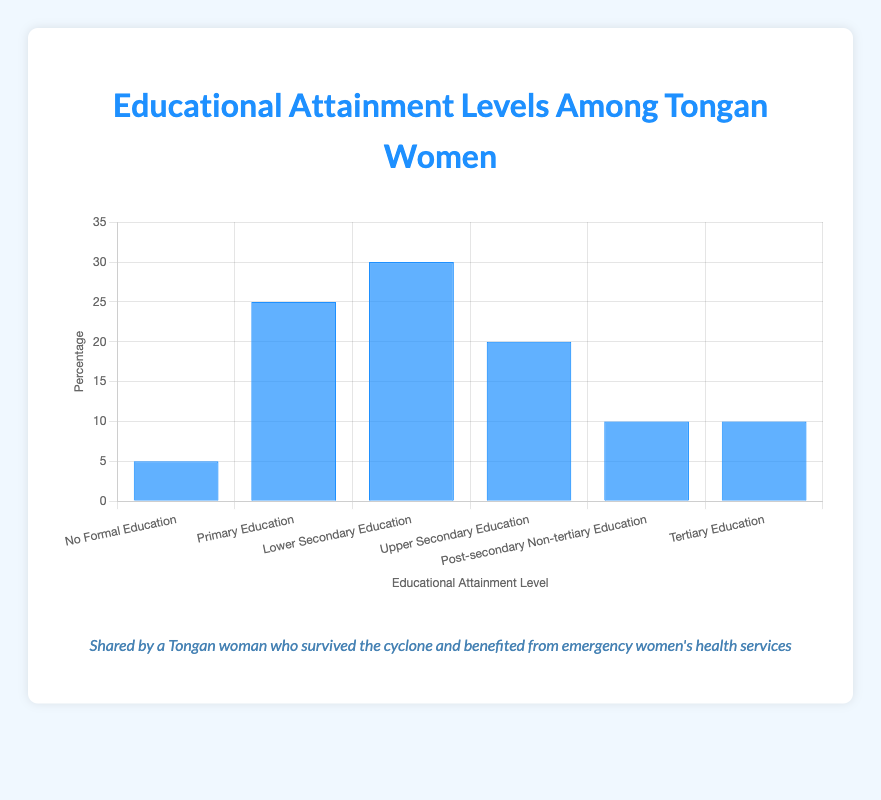What percentage of Tongan women have a Lower Secondary Education? To find this value, look at the bar corresponding to "Lower Secondary Education" and check its height or the number labeled at the top of the bar. The height of this bar indicates the percentage.
Answer: 30 Which educational attainment level has the highest percentage of Tongan women? Look for the tallest bar among all the bars in the chart. The tallest bar represents the highest percentage.
Answer: Lower Secondary Education What is the combined percentage of Tongan women with Tertiary Education and Post-secondary Non-tertiary Education? Locate the bars for "Tertiary Education" and "Post-secondary Non-tertiary Education", and note their heights (both are 10). Add these two percentages together: 10 + 10.
Answer: 20 What is the difference in percentage between Tongan women with no formal education and those with primary education? Find the bars for "No Formal Education" and "Primary Education". The heights are 5% and 25% respectively. Subtract the smaller percentage from the larger one: 25 - 5.
Answer: 20 Which two educational levels share the same percentage of Tongan women? Compare the heights of the bars to identify any pairs with identical heights. Both the "Post-secondary Non-tertiary Education" and "Tertiary Education" bars have the same height, indicating they have the same percentage.
Answer: Post-secondary Non-tertiary Education and Tertiary Education How much higher is the percentage of Tongan women with Upper Secondary Education compared to those with No Formal Education? Look at the heights of the bars for "Upper Secondary Education" (20%) and "No Formal Education" (5%). Subtract the smaller percentage from the larger one: 20 - 5.
Answer: 15 What percentage of Tongan women have at least a secondary education (Lower Secondary and above)? Sum the percentages for "Lower Secondary Education", "Upper Secondary Education", "Post-secondary Non-tertiary Education", and "Tertiary Education": 30 + 20 + 10 + 10.
Answer: 70 If the category with the lowest percentage were to double its percentage, what would the new value be? Identify the category with the lowest percentage, which is "No Formal Education" at 5%. Doubling this percentage results in 5 * 2.
Answer: 10 Rank the educational attainment levels from highest to lowest percentage of Tongan women. List the categories based on the heights of their bars from the tallest to the shortest: Lower Secondary Education, Primary Education, Upper Secondary Education, Post-secondary Non-tertiary Education, Tertiary Education, No Formal Education.
Answer: Lower Secondary Education, Primary Education, Upper Secondary Education, Post-secondary Non-tertiary Education, Tertiary Education, No Formal Education 